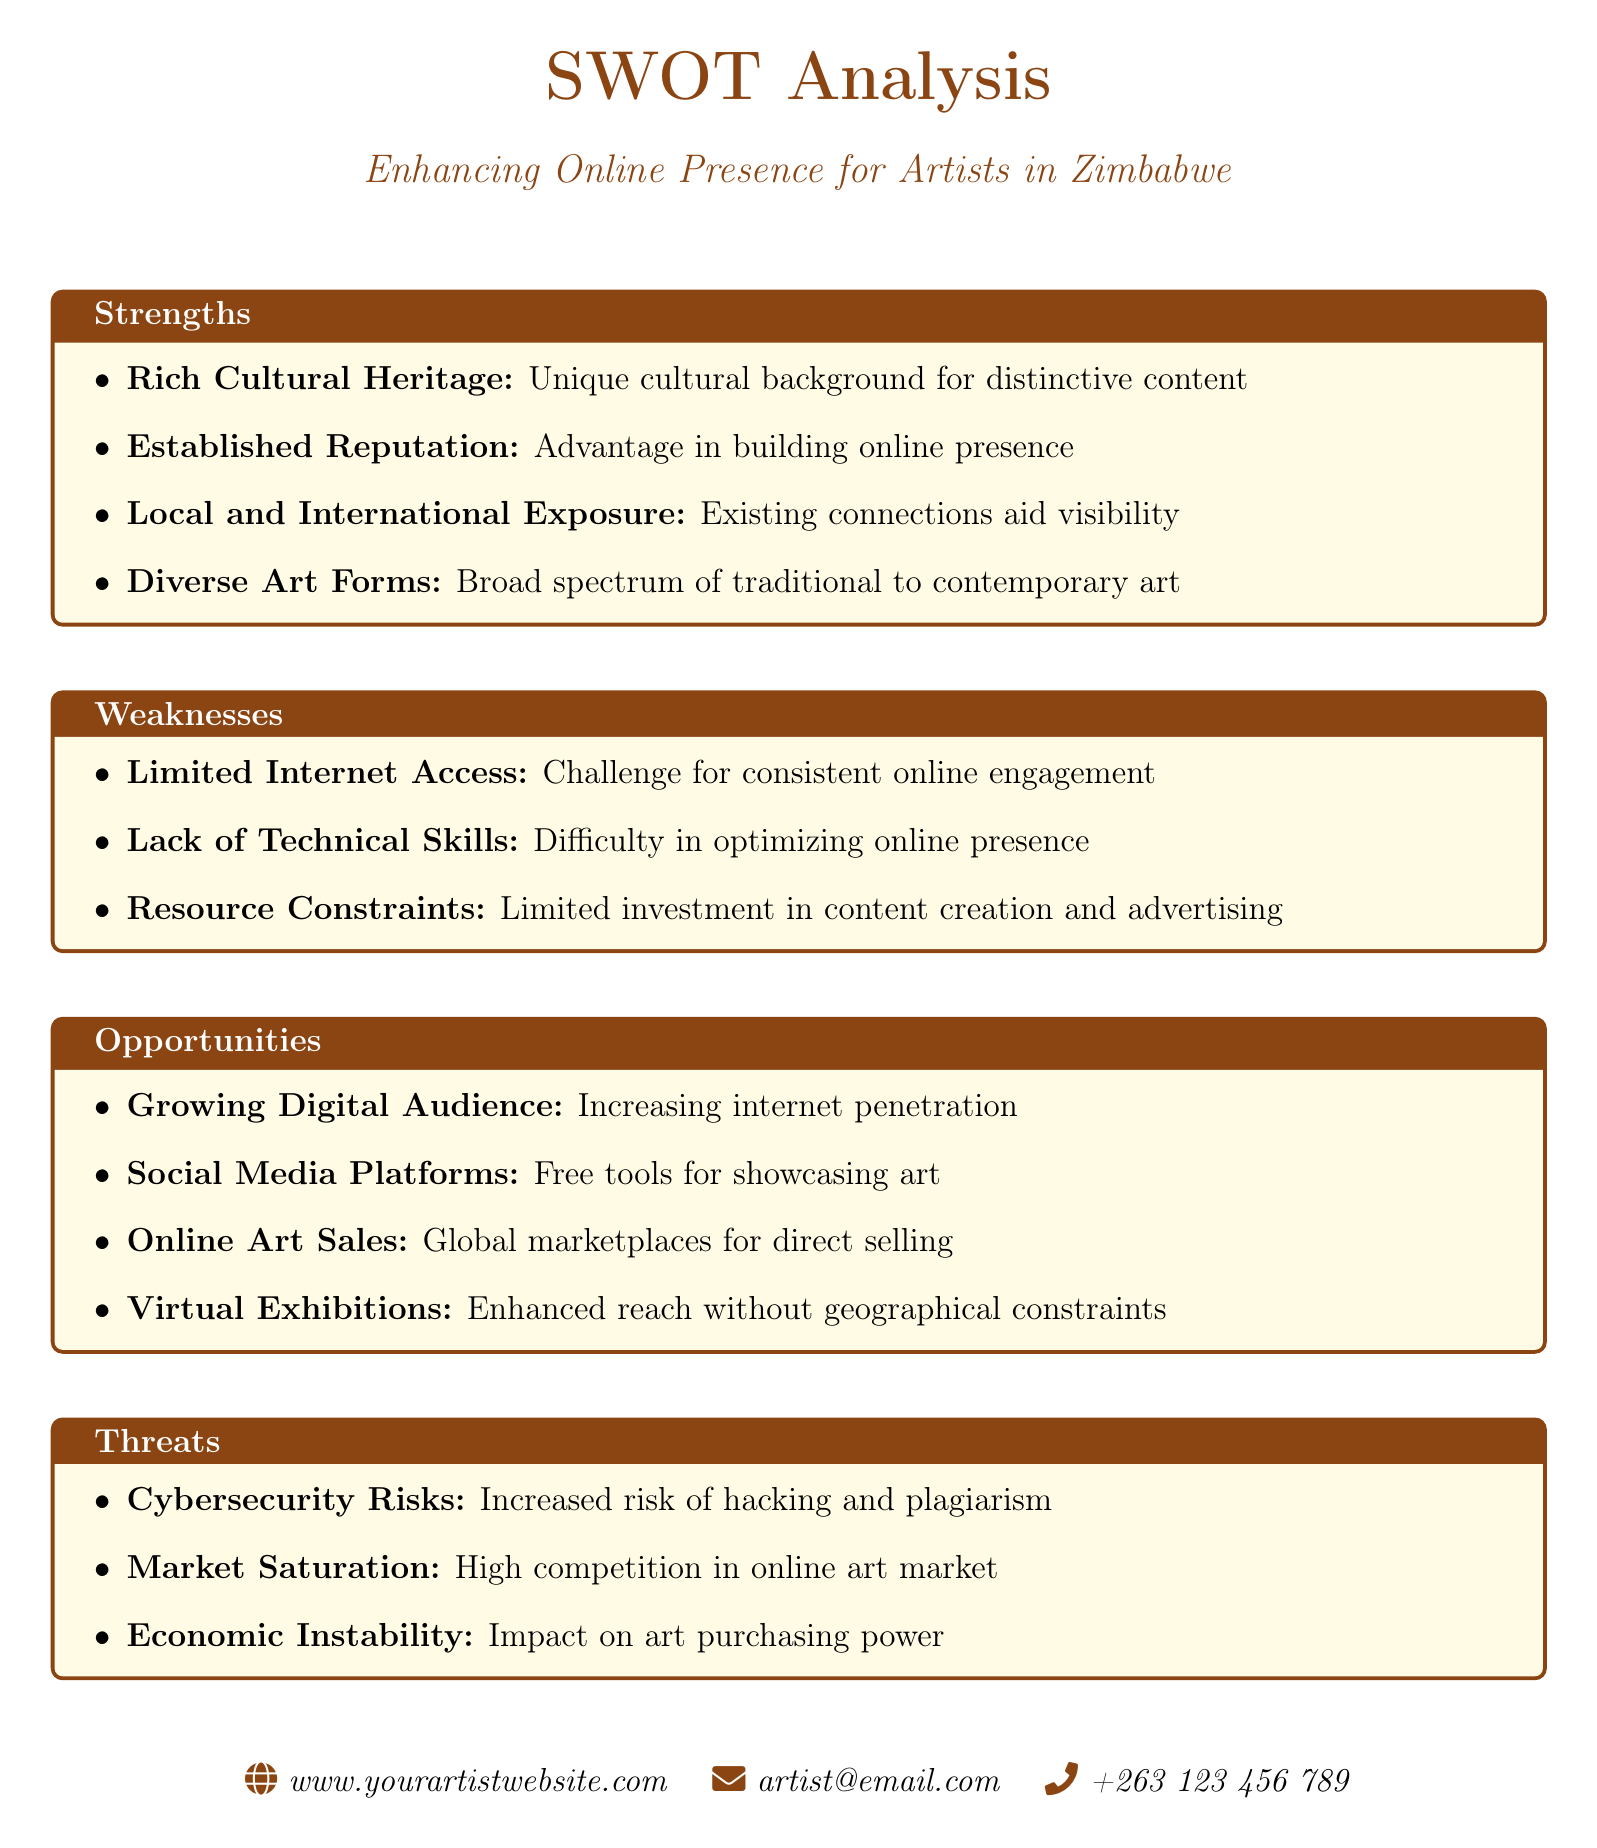what is one strength of artists in Zimbabwe? The document lists several strengths of artists in Zimbabwe, one of which is their unique cultural background for distinctive content.
Answer: Rich Cultural Heritage what is a weakness highlighted for artists regarding technology? The document indicates that a specific weakness for artists is the difficulty related to technology, which is a lack of technical skills for online presence.
Answer: Lack of Technical Skills how can artists in Zimbabwe benefit from online platforms? The document mentions that artists can showcase their art using free tools available on social media platforms.
Answer: Social Media Platforms what is an opportunity for enhancing online presence? The document identifies the increasing internet penetration as a significant opportunity for artists.
Answer: Growing Digital Audience what is one threat mentioned in the SWOT analysis? The document points out cybersecurity risks as a threat to artists' online presence.
Answer: Cybersecurity Risks how many strengths are listed in the document? There are four strengths outlined in the SWOT analysis.
Answer: 4 which type of exhibitions is mentioned as an opportunity for broader reach? The document discusses virtual exhibitions as a means to enhance reach without geographical constraints.
Answer: Virtual Exhibitions what economic factor is identified as a threat in the document? The document notes economic instability as impacting art purchasing power, making it a threat.
Answer: Economic Instability 